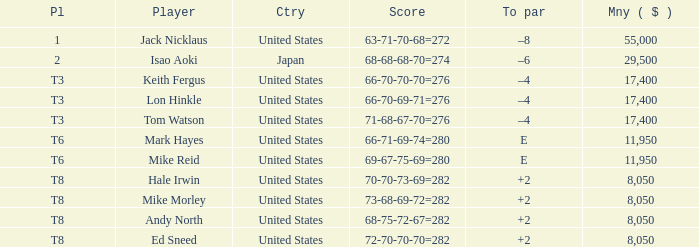I'm looking to parse the entire table for insights. Could you assist me with that? {'header': ['Pl', 'Player', 'Ctry', 'Score', 'To par', 'Mny ( $ )'], 'rows': [['1', 'Jack Nicklaus', 'United States', '63-71-70-68=272', '–8', '55,000'], ['2', 'Isao Aoki', 'Japan', '68-68-68-70=274', '–6', '29,500'], ['T3', 'Keith Fergus', 'United States', '66-70-70-70=276', '–4', '17,400'], ['T3', 'Lon Hinkle', 'United States', '66-70-69-71=276', '–4', '17,400'], ['T3', 'Tom Watson', 'United States', '71-68-67-70=276', '–4', '17,400'], ['T6', 'Mark Hayes', 'United States', '66-71-69-74=280', 'E', '11,950'], ['T6', 'Mike Reid', 'United States', '69-67-75-69=280', 'E', '11,950'], ['T8', 'Hale Irwin', 'United States', '70-70-73-69=282', '+2', '8,050'], ['T8', 'Mike Morley', 'United States', '73-68-69-72=282', '+2', '8,050'], ['T8', 'Andy North', 'United States', '68-75-72-67=282', '+2', '8,050'], ['T8', 'Ed Sneed', 'United States', '72-70-70-70=282', '+2', '8,050']]} Identify the player who has earned above 11,950, secured a place in the top 8, and achieved scores of 73-68-69-72, resulting in an None. 